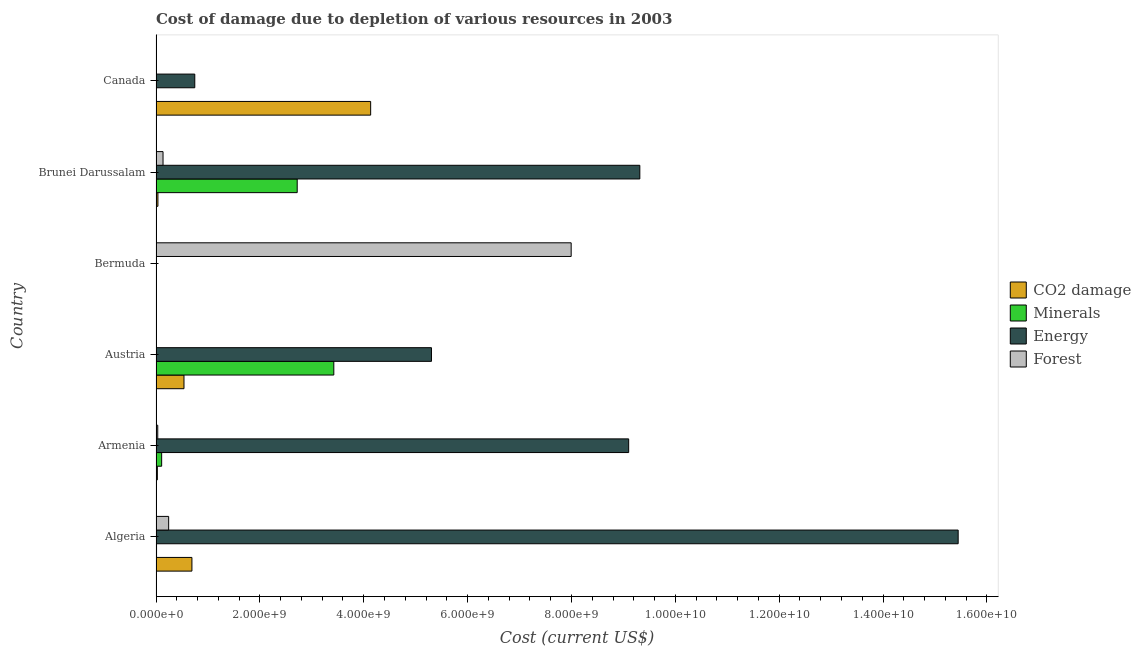How many groups of bars are there?
Your answer should be compact. 6. Are the number of bars per tick equal to the number of legend labels?
Make the answer very short. Yes. Are the number of bars on each tick of the Y-axis equal?
Offer a terse response. Yes. How many bars are there on the 4th tick from the top?
Your response must be concise. 4. How many bars are there on the 4th tick from the bottom?
Provide a short and direct response. 4. What is the label of the 2nd group of bars from the top?
Your response must be concise. Brunei Darussalam. In how many cases, is the number of bars for a given country not equal to the number of legend labels?
Make the answer very short. 0. What is the cost of damage due to depletion of coal in Bermuda?
Make the answer very short. 3.81e+06. Across all countries, what is the maximum cost of damage due to depletion of energy?
Offer a terse response. 1.54e+1. Across all countries, what is the minimum cost of damage due to depletion of minerals?
Offer a terse response. 3.92e+04. In which country was the cost of damage due to depletion of energy maximum?
Make the answer very short. Algeria. In which country was the cost of damage due to depletion of minerals minimum?
Offer a terse response. Bermuda. What is the total cost of damage due to depletion of energy in the graph?
Make the answer very short. 3.99e+1. What is the difference between the cost of damage due to depletion of coal in Armenia and that in Canada?
Your answer should be compact. -4.11e+09. What is the difference between the cost of damage due to depletion of coal in Austria and the cost of damage due to depletion of minerals in Algeria?
Your answer should be very brief. 5.28e+08. What is the average cost of damage due to depletion of coal per country?
Your response must be concise. 9.05e+08. What is the difference between the cost of damage due to depletion of forests and cost of damage due to depletion of minerals in Canada?
Provide a succinct answer. 7.98e+06. In how many countries, is the cost of damage due to depletion of energy greater than 6800000000 US$?
Keep it short and to the point. 3. What is the ratio of the cost of damage due to depletion of minerals in Armenia to that in Bermuda?
Your answer should be very brief. 2763.47. Is the difference between the cost of damage due to depletion of minerals in Bermuda and Brunei Darussalam greater than the difference between the cost of damage due to depletion of forests in Bermuda and Brunei Darussalam?
Ensure brevity in your answer.  No. What is the difference between the highest and the second highest cost of damage due to depletion of minerals?
Keep it short and to the point. 7.05e+08. What is the difference between the highest and the lowest cost of damage due to depletion of energy?
Your response must be concise. 1.54e+1. What does the 4th bar from the top in Bermuda represents?
Ensure brevity in your answer.  CO2 damage. What does the 2nd bar from the bottom in Brunei Darussalam represents?
Offer a very short reply. Minerals. How many countries are there in the graph?
Offer a terse response. 6. Are the values on the major ticks of X-axis written in scientific E-notation?
Your response must be concise. Yes. Does the graph contain any zero values?
Give a very brief answer. No. How are the legend labels stacked?
Your response must be concise. Vertical. What is the title of the graph?
Ensure brevity in your answer.  Cost of damage due to depletion of various resources in 2003 . What is the label or title of the X-axis?
Make the answer very short. Cost (current US$). What is the label or title of the Y-axis?
Ensure brevity in your answer.  Country. What is the Cost (current US$) of CO2 damage in Algeria?
Offer a very short reply. 6.91e+08. What is the Cost (current US$) in Minerals in Algeria?
Your answer should be very brief. 1.02e+07. What is the Cost (current US$) of Energy in Algeria?
Give a very brief answer. 1.54e+1. What is the Cost (current US$) of Forest in Algeria?
Your answer should be very brief. 2.43e+08. What is the Cost (current US$) in CO2 damage in Armenia?
Provide a short and direct response. 2.56e+07. What is the Cost (current US$) of Minerals in Armenia?
Provide a short and direct response. 1.08e+08. What is the Cost (current US$) of Energy in Armenia?
Offer a terse response. 9.10e+09. What is the Cost (current US$) of Forest in Armenia?
Provide a short and direct response. 3.32e+07. What is the Cost (current US$) of CO2 damage in Austria?
Your answer should be compact. 5.38e+08. What is the Cost (current US$) in Minerals in Austria?
Your answer should be compact. 3.42e+09. What is the Cost (current US$) of Energy in Austria?
Make the answer very short. 5.30e+09. What is the Cost (current US$) of Forest in Austria?
Give a very brief answer. 1.20e+05. What is the Cost (current US$) in CO2 damage in Bermuda?
Offer a very short reply. 3.81e+06. What is the Cost (current US$) of Minerals in Bermuda?
Provide a short and direct response. 3.92e+04. What is the Cost (current US$) of Energy in Bermuda?
Your answer should be very brief. 1.57e+06. What is the Cost (current US$) in Forest in Bermuda?
Provide a short and direct response. 7.99e+09. What is the Cost (current US$) of CO2 damage in Brunei Darussalam?
Provide a short and direct response. 3.64e+07. What is the Cost (current US$) in Minerals in Brunei Darussalam?
Your answer should be very brief. 2.72e+09. What is the Cost (current US$) in Energy in Brunei Darussalam?
Give a very brief answer. 9.32e+09. What is the Cost (current US$) of Forest in Brunei Darussalam?
Give a very brief answer. 1.35e+08. What is the Cost (current US$) of CO2 damage in Canada?
Provide a short and direct response. 4.13e+09. What is the Cost (current US$) of Minerals in Canada?
Offer a very short reply. 1.34e+06. What is the Cost (current US$) of Energy in Canada?
Your answer should be very brief. 7.46e+08. What is the Cost (current US$) of Forest in Canada?
Make the answer very short. 9.33e+06. Across all countries, what is the maximum Cost (current US$) in CO2 damage?
Ensure brevity in your answer.  4.13e+09. Across all countries, what is the maximum Cost (current US$) of Minerals?
Keep it short and to the point. 3.42e+09. Across all countries, what is the maximum Cost (current US$) of Energy?
Your answer should be very brief. 1.54e+1. Across all countries, what is the maximum Cost (current US$) of Forest?
Offer a terse response. 7.99e+09. Across all countries, what is the minimum Cost (current US$) of CO2 damage?
Ensure brevity in your answer.  3.81e+06. Across all countries, what is the minimum Cost (current US$) of Minerals?
Provide a succinct answer. 3.92e+04. Across all countries, what is the minimum Cost (current US$) of Energy?
Provide a short and direct response. 1.57e+06. Across all countries, what is the minimum Cost (current US$) in Forest?
Your answer should be compact. 1.20e+05. What is the total Cost (current US$) in CO2 damage in the graph?
Make the answer very short. 5.43e+09. What is the total Cost (current US$) in Minerals in the graph?
Offer a very short reply. 6.26e+09. What is the total Cost (current US$) of Energy in the graph?
Give a very brief answer. 3.99e+1. What is the total Cost (current US$) of Forest in the graph?
Provide a succinct answer. 8.42e+09. What is the difference between the Cost (current US$) of CO2 damage in Algeria and that in Armenia?
Give a very brief answer. 6.66e+08. What is the difference between the Cost (current US$) of Minerals in Algeria and that in Armenia?
Ensure brevity in your answer.  -9.81e+07. What is the difference between the Cost (current US$) in Energy in Algeria and that in Armenia?
Your response must be concise. 6.34e+09. What is the difference between the Cost (current US$) of Forest in Algeria and that in Armenia?
Ensure brevity in your answer.  2.10e+08. What is the difference between the Cost (current US$) in CO2 damage in Algeria and that in Austria?
Your answer should be very brief. 1.53e+08. What is the difference between the Cost (current US$) in Minerals in Algeria and that in Austria?
Provide a succinct answer. -3.41e+09. What is the difference between the Cost (current US$) in Energy in Algeria and that in Austria?
Your answer should be very brief. 1.01e+1. What is the difference between the Cost (current US$) in Forest in Algeria and that in Austria?
Offer a terse response. 2.43e+08. What is the difference between the Cost (current US$) in CO2 damage in Algeria and that in Bermuda?
Ensure brevity in your answer.  6.88e+08. What is the difference between the Cost (current US$) in Minerals in Algeria and that in Bermuda?
Offer a very short reply. 1.02e+07. What is the difference between the Cost (current US$) of Energy in Algeria and that in Bermuda?
Offer a terse response. 1.54e+1. What is the difference between the Cost (current US$) in Forest in Algeria and that in Bermuda?
Your response must be concise. -7.75e+09. What is the difference between the Cost (current US$) in CO2 damage in Algeria and that in Brunei Darussalam?
Ensure brevity in your answer.  6.55e+08. What is the difference between the Cost (current US$) in Minerals in Algeria and that in Brunei Darussalam?
Offer a very short reply. -2.71e+09. What is the difference between the Cost (current US$) of Energy in Algeria and that in Brunei Darussalam?
Offer a terse response. 6.13e+09. What is the difference between the Cost (current US$) in Forest in Algeria and that in Brunei Darussalam?
Your answer should be very brief. 1.08e+08. What is the difference between the Cost (current US$) of CO2 damage in Algeria and that in Canada?
Give a very brief answer. -3.44e+09. What is the difference between the Cost (current US$) of Minerals in Algeria and that in Canada?
Provide a succinct answer. 8.87e+06. What is the difference between the Cost (current US$) in Energy in Algeria and that in Canada?
Provide a short and direct response. 1.47e+1. What is the difference between the Cost (current US$) in Forest in Algeria and that in Canada?
Your response must be concise. 2.34e+08. What is the difference between the Cost (current US$) in CO2 damage in Armenia and that in Austria?
Make the answer very short. -5.13e+08. What is the difference between the Cost (current US$) in Minerals in Armenia and that in Austria?
Your answer should be very brief. -3.32e+09. What is the difference between the Cost (current US$) in Energy in Armenia and that in Austria?
Provide a succinct answer. 3.80e+09. What is the difference between the Cost (current US$) of Forest in Armenia and that in Austria?
Provide a succinct answer. 3.31e+07. What is the difference between the Cost (current US$) in CO2 damage in Armenia and that in Bermuda?
Offer a terse response. 2.18e+07. What is the difference between the Cost (current US$) in Minerals in Armenia and that in Bermuda?
Keep it short and to the point. 1.08e+08. What is the difference between the Cost (current US$) of Energy in Armenia and that in Bermuda?
Keep it short and to the point. 9.10e+09. What is the difference between the Cost (current US$) of Forest in Armenia and that in Bermuda?
Make the answer very short. -7.96e+09. What is the difference between the Cost (current US$) in CO2 damage in Armenia and that in Brunei Darussalam?
Provide a short and direct response. -1.08e+07. What is the difference between the Cost (current US$) in Minerals in Armenia and that in Brunei Darussalam?
Your answer should be very brief. -2.61e+09. What is the difference between the Cost (current US$) of Energy in Armenia and that in Brunei Darussalam?
Your answer should be very brief. -2.15e+08. What is the difference between the Cost (current US$) of Forest in Armenia and that in Brunei Darussalam?
Offer a very short reply. -1.02e+08. What is the difference between the Cost (current US$) in CO2 damage in Armenia and that in Canada?
Your response must be concise. -4.11e+09. What is the difference between the Cost (current US$) of Minerals in Armenia and that in Canada?
Provide a succinct answer. 1.07e+08. What is the difference between the Cost (current US$) of Energy in Armenia and that in Canada?
Make the answer very short. 8.35e+09. What is the difference between the Cost (current US$) of Forest in Armenia and that in Canada?
Make the answer very short. 2.39e+07. What is the difference between the Cost (current US$) in CO2 damage in Austria and that in Bermuda?
Provide a short and direct response. 5.35e+08. What is the difference between the Cost (current US$) of Minerals in Austria and that in Bermuda?
Make the answer very short. 3.42e+09. What is the difference between the Cost (current US$) in Energy in Austria and that in Bermuda?
Your response must be concise. 5.30e+09. What is the difference between the Cost (current US$) in Forest in Austria and that in Bermuda?
Provide a short and direct response. -7.99e+09. What is the difference between the Cost (current US$) in CO2 damage in Austria and that in Brunei Darussalam?
Offer a terse response. 5.02e+08. What is the difference between the Cost (current US$) in Minerals in Austria and that in Brunei Darussalam?
Give a very brief answer. 7.05e+08. What is the difference between the Cost (current US$) of Energy in Austria and that in Brunei Darussalam?
Keep it short and to the point. -4.01e+09. What is the difference between the Cost (current US$) of Forest in Austria and that in Brunei Darussalam?
Your answer should be very brief. -1.35e+08. What is the difference between the Cost (current US$) in CO2 damage in Austria and that in Canada?
Provide a succinct answer. -3.59e+09. What is the difference between the Cost (current US$) of Minerals in Austria and that in Canada?
Ensure brevity in your answer.  3.42e+09. What is the difference between the Cost (current US$) in Energy in Austria and that in Canada?
Ensure brevity in your answer.  4.56e+09. What is the difference between the Cost (current US$) of Forest in Austria and that in Canada?
Give a very brief answer. -9.21e+06. What is the difference between the Cost (current US$) in CO2 damage in Bermuda and that in Brunei Darussalam?
Ensure brevity in your answer.  -3.26e+07. What is the difference between the Cost (current US$) in Minerals in Bermuda and that in Brunei Darussalam?
Your response must be concise. -2.72e+09. What is the difference between the Cost (current US$) in Energy in Bermuda and that in Brunei Darussalam?
Offer a very short reply. -9.31e+09. What is the difference between the Cost (current US$) of Forest in Bermuda and that in Brunei Darussalam?
Offer a terse response. 7.86e+09. What is the difference between the Cost (current US$) in CO2 damage in Bermuda and that in Canada?
Give a very brief answer. -4.13e+09. What is the difference between the Cost (current US$) in Minerals in Bermuda and that in Canada?
Offer a terse response. -1.31e+06. What is the difference between the Cost (current US$) in Energy in Bermuda and that in Canada?
Ensure brevity in your answer.  -7.45e+08. What is the difference between the Cost (current US$) in Forest in Bermuda and that in Canada?
Keep it short and to the point. 7.98e+09. What is the difference between the Cost (current US$) of CO2 damage in Brunei Darussalam and that in Canada?
Ensure brevity in your answer.  -4.10e+09. What is the difference between the Cost (current US$) in Minerals in Brunei Darussalam and that in Canada?
Your answer should be very brief. 2.72e+09. What is the difference between the Cost (current US$) in Energy in Brunei Darussalam and that in Canada?
Ensure brevity in your answer.  8.57e+09. What is the difference between the Cost (current US$) of Forest in Brunei Darussalam and that in Canada?
Offer a very short reply. 1.26e+08. What is the difference between the Cost (current US$) of CO2 damage in Algeria and the Cost (current US$) of Minerals in Armenia?
Provide a succinct answer. 5.83e+08. What is the difference between the Cost (current US$) in CO2 damage in Algeria and the Cost (current US$) in Energy in Armenia?
Provide a short and direct response. -8.41e+09. What is the difference between the Cost (current US$) of CO2 damage in Algeria and the Cost (current US$) of Forest in Armenia?
Provide a succinct answer. 6.58e+08. What is the difference between the Cost (current US$) in Minerals in Algeria and the Cost (current US$) in Energy in Armenia?
Your response must be concise. -9.09e+09. What is the difference between the Cost (current US$) in Minerals in Algeria and the Cost (current US$) in Forest in Armenia?
Provide a succinct answer. -2.30e+07. What is the difference between the Cost (current US$) in Energy in Algeria and the Cost (current US$) in Forest in Armenia?
Provide a succinct answer. 1.54e+1. What is the difference between the Cost (current US$) in CO2 damage in Algeria and the Cost (current US$) in Minerals in Austria?
Keep it short and to the point. -2.73e+09. What is the difference between the Cost (current US$) of CO2 damage in Algeria and the Cost (current US$) of Energy in Austria?
Keep it short and to the point. -4.61e+09. What is the difference between the Cost (current US$) in CO2 damage in Algeria and the Cost (current US$) in Forest in Austria?
Give a very brief answer. 6.91e+08. What is the difference between the Cost (current US$) in Minerals in Algeria and the Cost (current US$) in Energy in Austria?
Give a very brief answer. -5.29e+09. What is the difference between the Cost (current US$) in Minerals in Algeria and the Cost (current US$) in Forest in Austria?
Offer a terse response. 1.01e+07. What is the difference between the Cost (current US$) of Energy in Algeria and the Cost (current US$) of Forest in Austria?
Offer a very short reply. 1.54e+1. What is the difference between the Cost (current US$) in CO2 damage in Algeria and the Cost (current US$) in Minerals in Bermuda?
Your answer should be very brief. 6.91e+08. What is the difference between the Cost (current US$) in CO2 damage in Algeria and the Cost (current US$) in Energy in Bermuda?
Offer a very short reply. 6.90e+08. What is the difference between the Cost (current US$) in CO2 damage in Algeria and the Cost (current US$) in Forest in Bermuda?
Keep it short and to the point. -7.30e+09. What is the difference between the Cost (current US$) of Minerals in Algeria and the Cost (current US$) of Energy in Bermuda?
Your response must be concise. 8.64e+06. What is the difference between the Cost (current US$) in Minerals in Algeria and the Cost (current US$) in Forest in Bermuda?
Your answer should be compact. -7.98e+09. What is the difference between the Cost (current US$) of Energy in Algeria and the Cost (current US$) of Forest in Bermuda?
Your answer should be compact. 7.45e+09. What is the difference between the Cost (current US$) of CO2 damage in Algeria and the Cost (current US$) of Minerals in Brunei Darussalam?
Your response must be concise. -2.03e+09. What is the difference between the Cost (current US$) in CO2 damage in Algeria and the Cost (current US$) in Energy in Brunei Darussalam?
Keep it short and to the point. -8.62e+09. What is the difference between the Cost (current US$) of CO2 damage in Algeria and the Cost (current US$) of Forest in Brunei Darussalam?
Offer a very short reply. 5.56e+08. What is the difference between the Cost (current US$) in Minerals in Algeria and the Cost (current US$) in Energy in Brunei Darussalam?
Your answer should be compact. -9.31e+09. What is the difference between the Cost (current US$) in Minerals in Algeria and the Cost (current US$) in Forest in Brunei Darussalam?
Your response must be concise. -1.25e+08. What is the difference between the Cost (current US$) of Energy in Algeria and the Cost (current US$) of Forest in Brunei Darussalam?
Ensure brevity in your answer.  1.53e+1. What is the difference between the Cost (current US$) in CO2 damage in Algeria and the Cost (current US$) in Minerals in Canada?
Keep it short and to the point. 6.90e+08. What is the difference between the Cost (current US$) in CO2 damage in Algeria and the Cost (current US$) in Energy in Canada?
Offer a terse response. -5.49e+07. What is the difference between the Cost (current US$) of CO2 damage in Algeria and the Cost (current US$) of Forest in Canada?
Your answer should be compact. 6.82e+08. What is the difference between the Cost (current US$) of Minerals in Algeria and the Cost (current US$) of Energy in Canada?
Ensure brevity in your answer.  -7.36e+08. What is the difference between the Cost (current US$) of Minerals in Algeria and the Cost (current US$) of Forest in Canada?
Ensure brevity in your answer.  8.91e+05. What is the difference between the Cost (current US$) in Energy in Algeria and the Cost (current US$) in Forest in Canada?
Your response must be concise. 1.54e+1. What is the difference between the Cost (current US$) of CO2 damage in Armenia and the Cost (current US$) of Minerals in Austria?
Provide a succinct answer. -3.40e+09. What is the difference between the Cost (current US$) of CO2 damage in Armenia and the Cost (current US$) of Energy in Austria?
Offer a terse response. -5.28e+09. What is the difference between the Cost (current US$) in CO2 damage in Armenia and the Cost (current US$) in Forest in Austria?
Provide a short and direct response. 2.55e+07. What is the difference between the Cost (current US$) in Minerals in Armenia and the Cost (current US$) in Energy in Austria?
Offer a terse response. -5.20e+09. What is the difference between the Cost (current US$) of Minerals in Armenia and the Cost (current US$) of Forest in Austria?
Ensure brevity in your answer.  1.08e+08. What is the difference between the Cost (current US$) in Energy in Armenia and the Cost (current US$) in Forest in Austria?
Your answer should be compact. 9.10e+09. What is the difference between the Cost (current US$) in CO2 damage in Armenia and the Cost (current US$) in Minerals in Bermuda?
Ensure brevity in your answer.  2.56e+07. What is the difference between the Cost (current US$) of CO2 damage in Armenia and the Cost (current US$) of Energy in Bermuda?
Provide a short and direct response. 2.40e+07. What is the difference between the Cost (current US$) of CO2 damage in Armenia and the Cost (current US$) of Forest in Bermuda?
Ensure brevity in your answer.  -7.97e+09. What is the difference between the Cost (current US$) of Minerals in Armenia and the Cost (current US$) of Energy in Bermuda?
Your answer should be very brief. 1.07e+08. What is the difference between the Cost (current US$) of Minerals in Armenia and the Cost (current US$) of Forest in Bermuda?
Provide a succinct answer. -7.89e+09. What is the difference between the Cost (current US$) in Energy in Armenia and the Cost (current US$) in Forest in Bermuda?
Your response must be concise. 1.11e+09. What is the difference between the Cost (current US$) in CO2 damage in Armenia and the Cost (current US$) in Minerals in Brunei Darussalam?
Provide a short and direct response. -2.69e+09. What is the difference between the Cost (current US$) in CO2 damage in Armenia and the Cost (current US$) in Energy in Brunei Darussalam?
Provide a short and direct response. -9.29e+09. What is the difference between the Cost (current US$) of CO2 damage in Armenia and the Cost (current US$) of Forest in Brunei Darussalam?
Your answer should be very brief. -1.09e+08. What is the difference between the Cost (current US$) of Minerals in Armenia and the Cost (current US$) of Energy in Brunei Darussalam?
Offer a very short reply. -9.21e+09. What is the difference between the Cost (current US$) of Minerals in Armenia and the Cost (current US$) of Forest in Brunei Darussalam?
Offer a terse response. -2.67e+07. What is the difference between the Cost (current US$) in Energy in Armenia and the Cost (current US$) in Forest in Brunei Darussalam?
Provide a succinct answer. 8.97e+09. What is the difference between the Cost (current US$) of CO2 damage in Armenia and the Cost (current US$) of Minerals in Canada?
Offer a terse response. 2.43e+07. What is the difference between the Cost (current US$) of CO2 damage in Armenia and the Cost (current US$) of Energy in Canada?
Your response must be concise. -7.21e+08. What is the difference between the Cost (current US$) of CO2 damage in Armenia and the Cost (current US$) of Forest in Canada?
Give a very brief answer. 1.63e+07. What is the difference between the Cost (current US$) of Minerals in Armenia and the Cost (current US$) of Energy in Canada?
Provide a succinct answer. -6.38e+08. What is the difference between the Cost (current US$) in Minerals in Armenia and the Cost (current US$) in Forest in Canada?
Provide a succinct answer. 9.90e+07. What is the difference between the Cost (current US$) of Energy in Armenia and the Cost (current US$) of Forest in Canada?
Provide a succinct answer. 9.09e+09. What is the difference between the Cost (current US$) in CO2 damage in Austria and the Cost (current US$) in Minerals in Bermuda?
Your answer should be very brief. 5.38e+08. What is the difference between the Cost (current US$) of CO2 damage in Austria and the Cost (current US$) of Energy in Bermuda?
Your response must be concise. 5.37e+08. What is the difference between the Cost (current US$) of CO2 damage in Austria and the Cost (current US$) of Forest in Bermuda?
Give a very brief answer. -7.46e+09. What is the difference between the Cost (current US$) of Minerals in Austria and the Cost (current US$) of Energy in Bermuda?
Provide a succinct answer. 3.42e+09. What is the difference between the Cost (current US$) in Minerals in Austria and the Cost (current US$) in Forest in Bermuda?
Give a very brief answer. -4.57e+09. What is the difference between the Cost (current US$) in Energy in Austria and the Cost (current US$) in Forest in Bermuda?
Make the answer very short. -2.69e+09. What is the difference between the Cost (current US$) in CO2 damage in Austria and the Cost (current US$) in Minerals in Brunei Darussalam?
Offer a terse response. -2.18e+09. What is the difference between the Cost (current US$) of CO2 damage in Austria and the Cost (current US$) of Energy in Brunei Darussalam?
Offer a very short reply. -8.78e+09. What is the difference between the Cost (current US$) of CO2 damage in Austria and the Cost (current US$) of Forest in Brunei Darussalam?
Offer a terse response. 4.03e+08. What is the difference between the Cost (current US$) of Minerals in Austria and the Cost (current US$) of Energy in Brunei Darussalam?
Offer a terse response. -5.89e+09. What is the difference between the Cost (current US$) in Minerals in Austria and the Cost (current US$) in Forest in Brunei Darussalam?
Provide a succinct answer. 3.29e+09. What is the difference between the Cost (current US$) in Energy in Austria and the Cost (current US$) in Forest in Brunei Darussalam?
Give a very brief answer. 5.17e+09. What is the difference between the Cost (current US$) of CO2 damage in Austria and the Cost (current US$) of Minerals in Canada?
Your response must be concise. 5.37e+08. What is the difference between the Cost (current US$) of CO2 damage in Austria and the Cost (current US$) of Energy in Canada?
Offer a very short reply. -2.08e+08. What is the difference between the Cost (current US$) in CO2 damage in Austria and the Cost (current US$) in Forest in Canada?
Provide a succinct answer. 5.29e+08. What is the difference between the Cost (current US$) of Minerals in Austria and the Cost (current US$) of Energy in Canada?
Provide a short and direct response. 2.68e+09. What is the difference between the Cost (current US$) in Minerals in Austria and the Cost (current US$) in Forest in Canada?
Offer a very short reply. 3.41e+09. What is the difference between the Cost (current US$) in Energy in Austria and the Cost (current US$) in Forest in Canada?
Offer a very short reply. 5.29e+09. What is the difference between the Cost (current US$) in CO2 damage in Bermuda and the Cost (current US$) in Minerals in Brunei Darussalam?
Ensure brevity in your answer.  -2.71e+09. What is the difference between the Cost (current US$) of CO2 damage in Bermuda and the Cost (current US$) of Energy in Brunei Darussalam?
Offer a terse response. -9.31e+09. What is the difference between the Cost (current US$) in CO2 damage in Bermuda and the Cost (current US$) in Forest in Brunei Darussalam?
Give a very brief answer. -1.31e+08. What is the difference between the Cost (current US$) in Minerals in Bermuda and the Cost (current US$) in Energy in Brunei Darussalam?
Your answer should be compact. -9.32e+09. What is the difference between the Cost (current US$) of Minerals in Bermuda and the Cost (current US$) of Forest in Brunei Darussalam?
Ensure brevity in your answer.  -1.35e+08. What is the difference between the Cost (current US$) in Energy in Bermuda and the Cost (current US$) in Forest in Brunei Darussalam?
Ensure brevity in your answer.  -1.33e+08. What is the difference between the Cost (current US$) of CO2 damage in Bermuda and the Cost (current US$) of Minerals in Canada?
Offer a very short reply. 2.46e+06. What is the difference between the Cost (current US$) in CO2 damage in Bermuda and the Cost (current US$) in Energy in Canada?
Your response must be concise. -7.42e+08. What is the difference between the Cost (current US$) of CO2 damage in Bermuda and the Cost (current US$) of Forest in Canada?
Give a very brief answer. -5.52e+06. What is the difference between the Cost (current US$) in Minerals in Bermuda and the Cost (current US$) in Energy in Canada?
Offer a terse response. -7.46e+08. What is the difference between the Cost (current US$) of Minerals in Bermuda and the Cost (current US$) of Forest in Canada?
Your answer should be compact. -9.29e+06. What is the difference between the Cost (current US$) in Energy in Bermuda and the Cost (current US$) in Forest in Canada?
Your answer should be very brief. -7.75e+06. What is the difference between the Cost (current US$) in CO2 damage in Brunei Darussalam and the Cost (current US$) in Minerals in Canada?
Provide a succinct answer. 3.51e+07. What is the difference between the Cost (current US$) in CO2 damage in Brunei Darussalam and the Cost (current US$) in Energy in Canada?
Offer a terse response. -7.10e+08. What is the difference between the Cost (current US$) in CO2 damage in Brunei Darussalam and the Cost (current US$) in Forest in Canada?
Ensure brevity in your answer.  2.71e+07. What is the difference between the Cost (current US$) of Minerals in Brunei Darussalam and the Cost (current US$) of Energy in Canada?
Keep it short and to the point. 1.97e+09. What is the difference between the Cost (current US$) in Minerals in Brunei Darussalam and the Cost (current US$) in Forest in Canada?
Keep it short and to the point. 2.71e+09. What is the difference between the Cost (current US$) in Energy in Brunei Darussalam and the Cost (current US$) in Forest in Canada?
Make the answer very short. 9.31e+09. What is the average Cost (current US$) in CO2 damage per country?
Your answer should be compact. 9.05e+08. What is the average Cost (current US$) of Minerals per country?
Keep it short and to the point. 1.04e+09. What is the average Cost (current US$) in Energy per country?
Keep it short and to the point. 6.65e+09. What is the average Cost (current US$) of Forest per country?
Provide a short and direct response. 1.40e+09. What is the difference between the Cost (current US$) of CO2 damage and Cost (current US$) of Minerals in Algeria?
Provide a short and direct response. 6.81e+08. What is the difference between the Cost (current US$) in CO2 damage and Cost (current US$) in Energy in Algeria?
Provide a short and direct response. -1.48e+1. What is the difference between the Cost (current US$) in CO2 damage and Cost (current US$) in Forest in Algeria?
Your response must be concise. 4.48e+08. What is the difference between the Cost (current US$) of Minerals and Cost (current US$) of Energy in Algeria?
Offer a very short reply. -1.54e+1. What is the difference between the Cost (current US$) of Minerals and Cost (current US$) of Forest in Algeria?
Your answer should be very brief. -2.33e+08. What is the difference between the Cost (current US$) of Energy and Cost (current US$) of Forest in Algeria?
Your response must be concise. 1.52e+1. What is the difference between the Cost (current US$) of CO2 damage and Cost (current US$) of Minerals in Armenia?
Provide a succinct answer. -8.27e+07. What is the difference between the Cost (current US$) of CO2 damage and Cost (current US$) of Energy in Armenia?
Your answer should be compact. -9.08e+09. What is the difference between the Cost (current US$) of CO2 damage and Cost (current US$) of Forest in Armenia?
Provide a succinct answer. -7.61e+06. What is the difference between the Cost (current US$) of Minerals and Cost (current US$) of Energy in Armenia?
Offer a very short reply. -8.99e+09. What is the difference between the Cost (current US$) of Minerals and Cost (current US$) of Forest in Armenia?
Ensure brevity in your answer.  7.51e+07. What is the difference between the Cost (current US$) in Energy and Cost (current US$) in Forest in Armenia?
Provide a succinct answer. 9.07e+09. What is the difference between the Cost (current US$) in CO2 damage and Cost (current US$) in Minerals in Austria?
Your response must be concise. -2.88e+09. What is the difference between the Cost (current US$) of CO2 damage and Cost (current US$) of Energy in Austria?
Make the answer very short. -4.77e+09. What is the difference between the Cost (current US$) of CO2 damage and Cost (current US$) of Forest in Austria?
Ensure brevity in your answer.  5.38e+08. What is the difference between the Cost (current US$) of Minerals and Cost (current US$) of Energy in Austria?
Provide a short and direct response. -1.88e+09. What is the difference between the Cost (current US$) in Minerals and Cost (current US$) in Forest in Austria?
Offer a very short reply. 3.42e+09. What is the difference between the Cost (current US$) of Energy and Cost (current US$) of Forest in Austria?
Provide a succinct answer. 5.30e+09. What is the difference between the Cost (current US$) in CO2 damage and Cost (current US$) in Minerals in Bermuda?
Your response must be concise. 3.77e+06. What is the difference between the Cost (current US$) of CO2 damage and Cost (current US$) of Energy in Bermuda?
Offer a very short reply. 2.24e+06. What is the difference between the Cost (current US$) of CO2 damage and Cost (current US$) of Forest in Bermuda?
Provide a short and direct response. -7.99e+09. What is the difference between the Cost (current US$) of Minerals and Cost (current US$) of Energy in Bermuda?
Offer a terse response. -1.53e+06. What is the difference between the Cost (current US$) in Minerals and Cost (current US$) in Forest in Bermuda?
Make the answer very short. -7.99e+09. What is the difference between the Cost (current US$) of Energy and Cost (current US$) of Forest in Bermuda?
Your answer should be very brief. -7.99e+09. What is the difference between the Cost (current US$) in CO2 damage and Cost (current US$) in Minerals in Brunei Darussalam?
Provide a short and direct response. -2.68e+09. What is the difference between the Cost (current US$) of CO2 damage and Cost (current US$) of Energy in Brunei Darussalam?
Give a very brief answer. -9.28e+09. What is the difference between the Cost (current US$) in CO2 damage and Cost (current US$) in Forest in Brunei Darussalam?
Offer a very short reply. -9.86e+07. What is the difference between the Cost (current US$) in Minerals and Cost (current US$) in Energy in Brunei Darussalam?
Offer a terse response. -6.60e+09. What is the difference between the Cost (current US$) in Minerals and Cost (current US$) in Forest in Brunei Darussalam?
Offer a terse response. 2.58e+09. What is the difference between the Cost (current US$) of Energy and Cost (current US$) of Forest in Brunei Darussalam?
Your answer should be very brief. 9.18e+09. What is the difference between the Cost (current US$) in CO2 damage and Cost (current US$) in Minerals in Canada?
Offer a terse response. 4.13e+09. What is the difference between the Cost (current US$) of CO2 damage and Cost (current US$) of Energy in Canada?
Provide a succinct answer. 3.39e+09. What is the difference between the Cost (current US$) of CO2 damage and Cost (current US$) of Forest in Canada?
Your answer should be compact. 4.12e+09. What is the difference between the Cost (current US$) in Minerals and Cost (current US$) in Energy in Canada?
Your answer should be compact. -7.45e+08. What is the difference between the Cost (current US$) of Minerals and Cost (current US$) of Forest in Canada?
Your answer should be compact. -7.98e+06. What is the difference between the Cost (current US$) of Energy and Cost (current US$) of Forest in Canada?
Your answer should be compact. 7.37e+08. What is the ratio of the Cost (current US$) in CO2 damage in Algeria to that in Armenia?
Ensure brevity in your answer.  26.99. What is the ratio of the Cost (current US$) of Minerals in Algeria to that in Armenia?
Provide a succinct answer. 0.09. What is the ratio of the Cost (current US$) of Energy in Algeria to that in Armenia?
Your answer should be compact. 1.7. What is the ratio of the Cost (current US$) in Forest in Algeria to that in Armenia?
Provide a short and direct response. 7.32. What is the ratio of the Cost (current US$) in CO2 damage in Algeria to that in Austria?
Offer a very short reply. 1.28. What is the ratio of the Cost (current US$) of Minerals in Algeria to that in Austria?
Make the answer very short. 0. What is the ratio of the Cost (current US$) of Energy in Algeria to that in Austria?
Ensure brevity in your answer.  2.91. What is the ratio of the Cost (current US$) in Forest in Algeria to that in Austria?
Ensure brevity in your answer.  2033.21. What is the ratio of the Cost (current US$) of CO2 damage in Algeria to that in Bermuda?
Your answer should be very brief. 181.54. What is the ratio of the Cost (current US$) in Minerals in Algeria to that in Bermuda?
Ensure brevity in your answer.  260.59. What is the ratio of the Cost (current US$) of Energy in Algeria to that in Bermuda?
Offer a terse response. 9819.9. What is the ratio of the Cost (current US$) in Forest in Algeria to that in Bermuda?
Your answer should be very brief. 0.03. What is the ratio of the Cost (current US$) of CO2 damage in Algeria to that in Brunei Darussalam?
Ensure brevity in your answer.  18.97. What is the ratio of the Cost (current US$) in Minerals in Algeria to that in Brunei Darussalam?
Provide a short and direct response. 0. What is the ratio of the Cost (current US$) in Energy in Algeria to that in Brunei Darussalam?
Offer a terse response. 1.66. What is the ratio of the Cost (current US$) of Forest in Algeria to that in Brunei Darussalam?
Your answer should be compact. 1.8. What is the ratio of the Cost (current US$) in CO2 damage in Algeria to that in Canada?
Give a very brief answer. 0.17. What is the ratio of the Cost (current US$) in Minerals in Algeria to that in Canada?
Make the answer very short. 7.6. What is the ratio of the Cost (current US$) of Energy in Algeria to that in Canada?
Your answer should be very brief. 20.7. What is the ratio of the Cost (current US$) in Forest in Algeria to that in Canada?
Offer a very short reply. 26.09. What is the ratio of the Cost (current US$) in CO2 damage in Armenia to that in Austria?
Provide a short and direct response. 0.05. What is the ratio of the Cost (current US$) in Minerals in Armenia to that in Austria?
Make the answer very short. 0.03. What is the ratio of the Cost (current US$) in Energy in Armenia to that in Austria?
Provide a succinct answer. 1.72. What is the ratio of the Cost (current US$) of Forest in Armenia to that in Austria?
Your answer should be compact. 277.6. What is the ratio of the Cost (current US$) of CO2 damage in Armenia to that in Bermuda?
Your answer should be very brief. 6.73. What is the ratio of the Cost (current US$) of Minerals in Armenia to that in Bermuda?
Offer a terse response. 2763.47. What is the ratio of the Cost (current US$) in Energy in Armenia to that in Bermuda?
Provide a short and direct response. 5786.18. What is the ratio of the Cost (current US$) of Forest in Armenia to that in Bermuda?
Provide a succinct answer. 0. What is the ratio of the Cost (current US$) of CO2 damage in Armenia to that in Brunei Darussalam?
Provide a short and direct response. 0.7. What is the ratio of the Cost (current US$) in Minerals in Armenia to that in Brunei Darussalam?
Ensure brevity in your answer.  0.04. What is the ratio of the Cost (current US$) of Energy in Armenia to that in Brunei Darussalam?
Your answer should be compact. 0.98. What is the ratio of the Cost (current US$) in Forest in Armenia to that in Brunei Darussalam?
Provide a succinct answer. 0.25. What is the ratio of the Cost (current US$) of CO2 damage in Armenia to that in Canada?
Keep it short and to the point. 0.01. What is the ratio of the Cost (current US$) of Minerals in Armenia to that in Canada?
Your response must be concise. 80.56. What is the ratio of the Cost (current US$) of Energy in Armenia to that in Canada?
Make the answer very short. 12.2. What is the ratio of the Cost (current US$) in Forest in Armenia to that in Canada?
Offer a very short reply. 3.56. What is the ratio of the Cost (current US$) in CO2 damage in Austria to that in Bermuda?
Ensure brevity in your answer.  141.4. What is the ratio of the Cost (current US$) in Minerals in Austria to that in Bermuda?
Your answer should be compact. 8.73e+04. What is the ratio of the Cost (current US$) of Energy in Austria to that in Bermuda?
Your answer should be compact. 3372.02. What is the ratio of the Cost (current US$) in CO2 damage in Austria to that in Brunei Darussalam?
Make the answer very short. 14.78. What is the ratio of the Cost (current US$) in Minerals in Austria to that in Brunei Darussalam?
Make the answer very short. 1.26. What is the ratio of the Cost (current US$) in Energy in Austria to that in Brunei Darussalam?
Offer a very short reply. 0.57. What is the ratio of the Cost (current US$) of Forest in Austria to that in Brunei Darussalam?
Your answer should be very brief. 0. What is the ratio of the Cost (current US$) of CO2 damage in Austria to that in Canada?
Your answer should be very brief. 0.13. What is the ratio of the Cost (current US$) in Minerals in Austria to that in Canada?
Ensure brevity in your answer.  2545.55. What is the ratio of the Cost (current US$) in Energy in Austria to that in Canada?
Keep it short and to the point. 7.11. What is the ratio of the Cost (current US$) in Forest in Austria to that in Canada?
Provide a short and direct response. 0.01. What is the ratio of the Cost (current US$) of CO2 damage in Bermuda to that in Brunei Darussalam?
Keep it short and to the point. 0.1. What is the ratio of the Cost (current US$) in Minerals in Bermuda to that in Brunei Darussalam?
Provide a short and direct response. 0. What is the ratio of the Cost (current US$) of Forest in Bermuda to that in Brunei Darussalam?
Ensure brevity in your answer.  59.2. What is the ratio of the Cost (current US$) of CO2 damage in Bermuda to that in Canada?
Provide a short and direct response. 0. What is the ratio of the Cost (current US$) of Minerals in Bermuda to that in Canada?
Provide a succinct answer. 0.03. What is the ratio of the Cost (current US$) of Energy in Bermuda to that in Canada?
Offer a very short reply. 0. What is the ratio of the Cost (current US$) in Forest in Bermuda to that in Canada?
Ensure brevity in your answer.  857.18. What is the ratio of the Cost (current US$) in CO2 damage in Brunei Darussalam to that in Canada?
Ensure brevity in your answer.  0.01. What is the ratio of the Cost (current US$) in Minerals in Brunei Darussalam to that in Canada?
Give a very brief answer. 2021.55. What is the ratio of the Cost (current US$) in Energy in Brunei Darussalam to that in Canada?
Make the answer very short. 12.48. What is the ratio of the Cost (current US$) of Forest in Brunei Darussalam to that in Canada?
Offer a very short reply. 14.48. What is the difference between the highest and the second highest Cost (current US$) in CO2 damage?
Make the answer very short. 3.44e+09. What is the difference between the highest and the second highest Cost (current US$) in Minerals?
Your answer should be very brief. 7.05e+08. What is the difference between the highest and the second highest Cost (current US$) in Energy?
Ensure brevity in your answer.  6.13e+09. What is the difference between the highest and the second highest Cost (current US$) of Forest?
Ensure brevity in your answer.  7.75e+09. What is the difference between the highest and the lowest Cost (current US$) of CO2 damage?
Offer a very short reply. 4.13e+09. What is the difference between the highest and the lowest Cost (current US$) in Minerals?
Provide a short and direct response. 3.42e+09. What is the difference between the highest and the lowest Cost (current US$) of Energy?
Offer a terse response. 1.54e+1. What is the difference between the highest and the lowest Cost (current US$) in Forest?
Make the answer very short. 7.99e+09. 